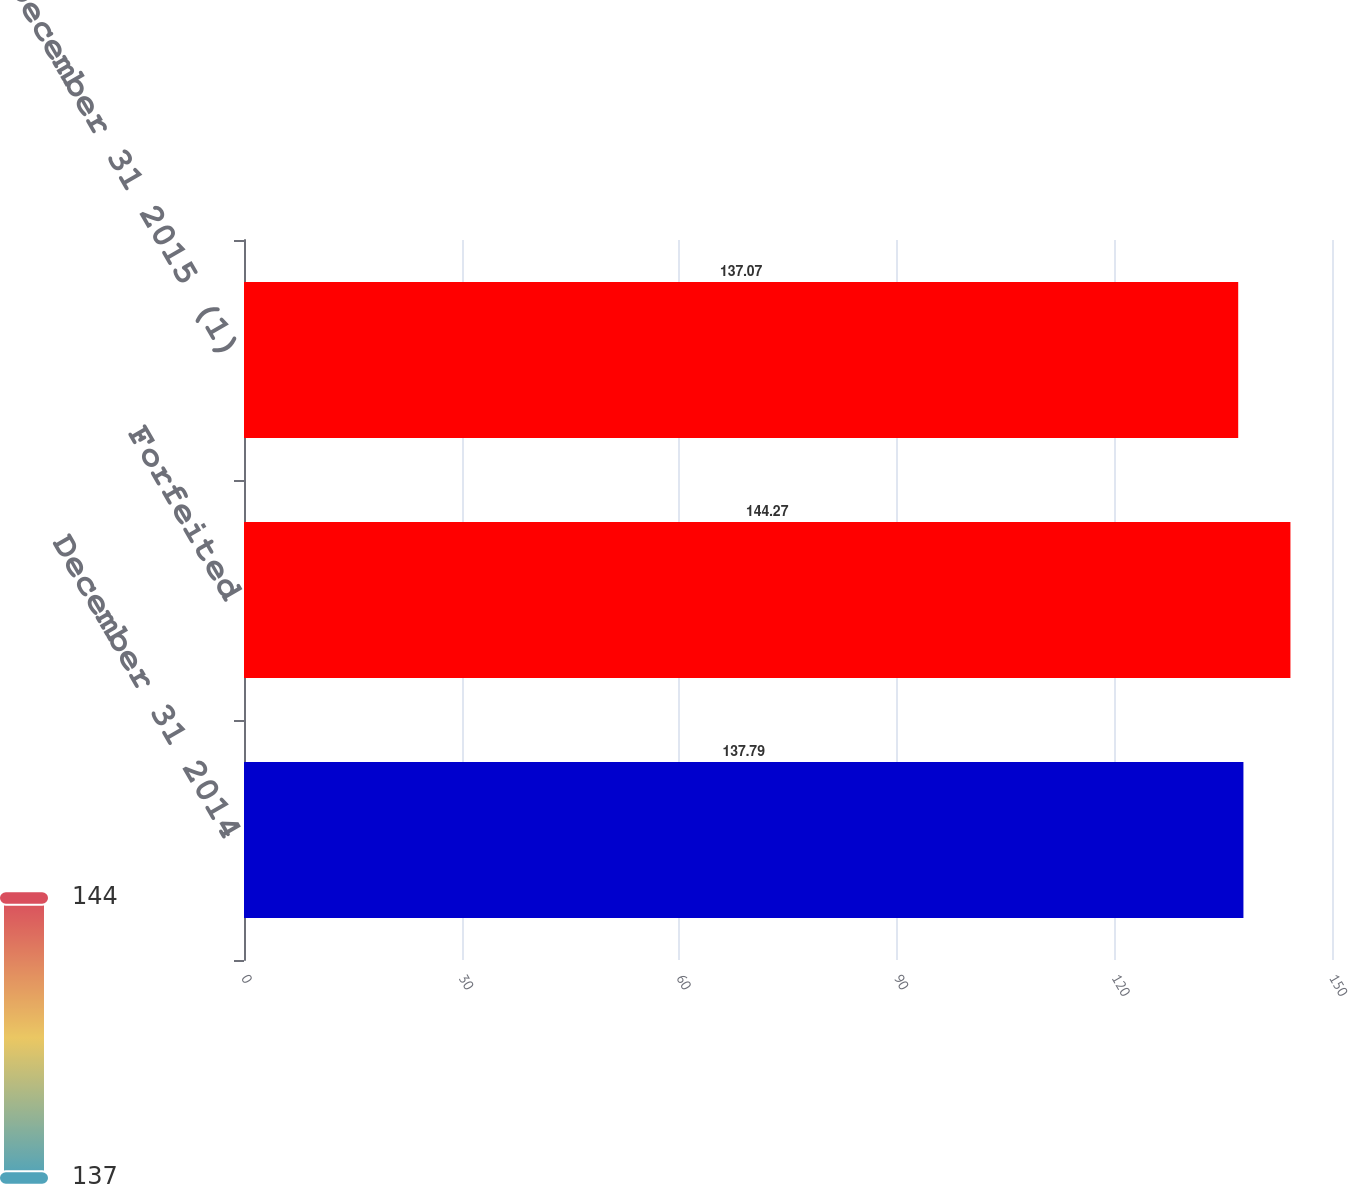Convert chart to OTSL. <chart><loc_0><loc_0><loc_500><loc_500><bar_chart><fcel>December 31 2014<fcel>Forfeited<fcel>December 31 2015 (1)<nl><fcel>137.79<fcel>144.27<fcel>137.07<nl></chart> 